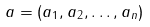<formula> <loc_0><loc_0><loc_500><loc_500>a = ( a _ { 1 } , a _ { 2 } , \dots , a _ { n } )</formula> 